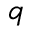<formula> <loc_0><loc_0><loc_500><loc_500>q</formula> 